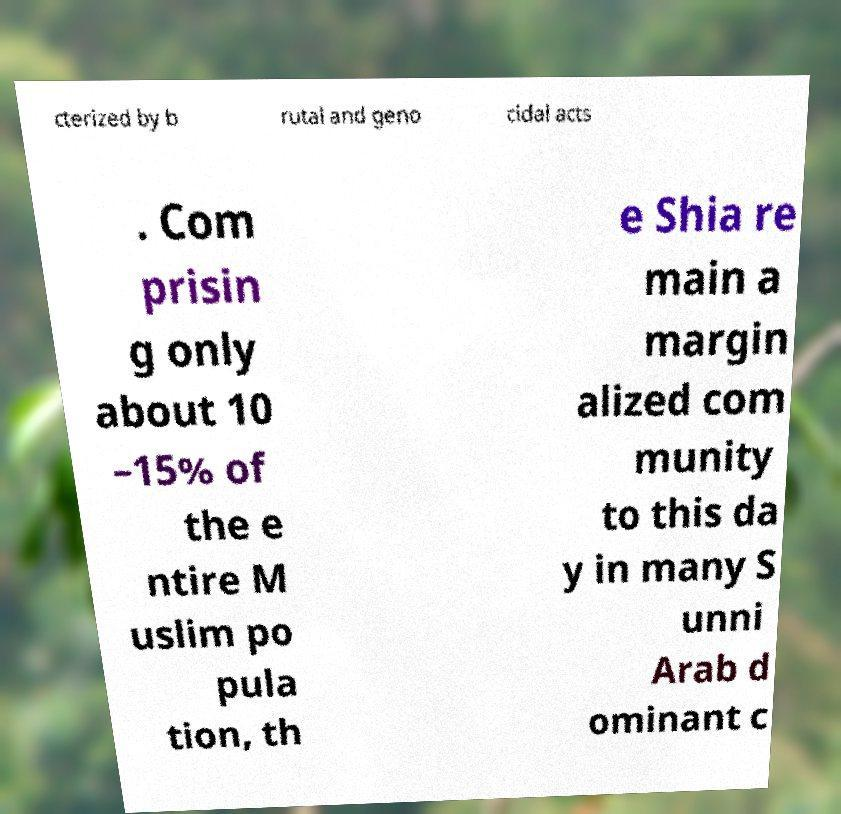Please read and relay the text visible in this image. What does it say? cterized by b rutal and geno cidal acts . Com prisin g only about 10 –15% of the e ntire M uslim po pula tion, th e Shia re main a margin alized com munity to this da y in many S unni Arab d ominant c 